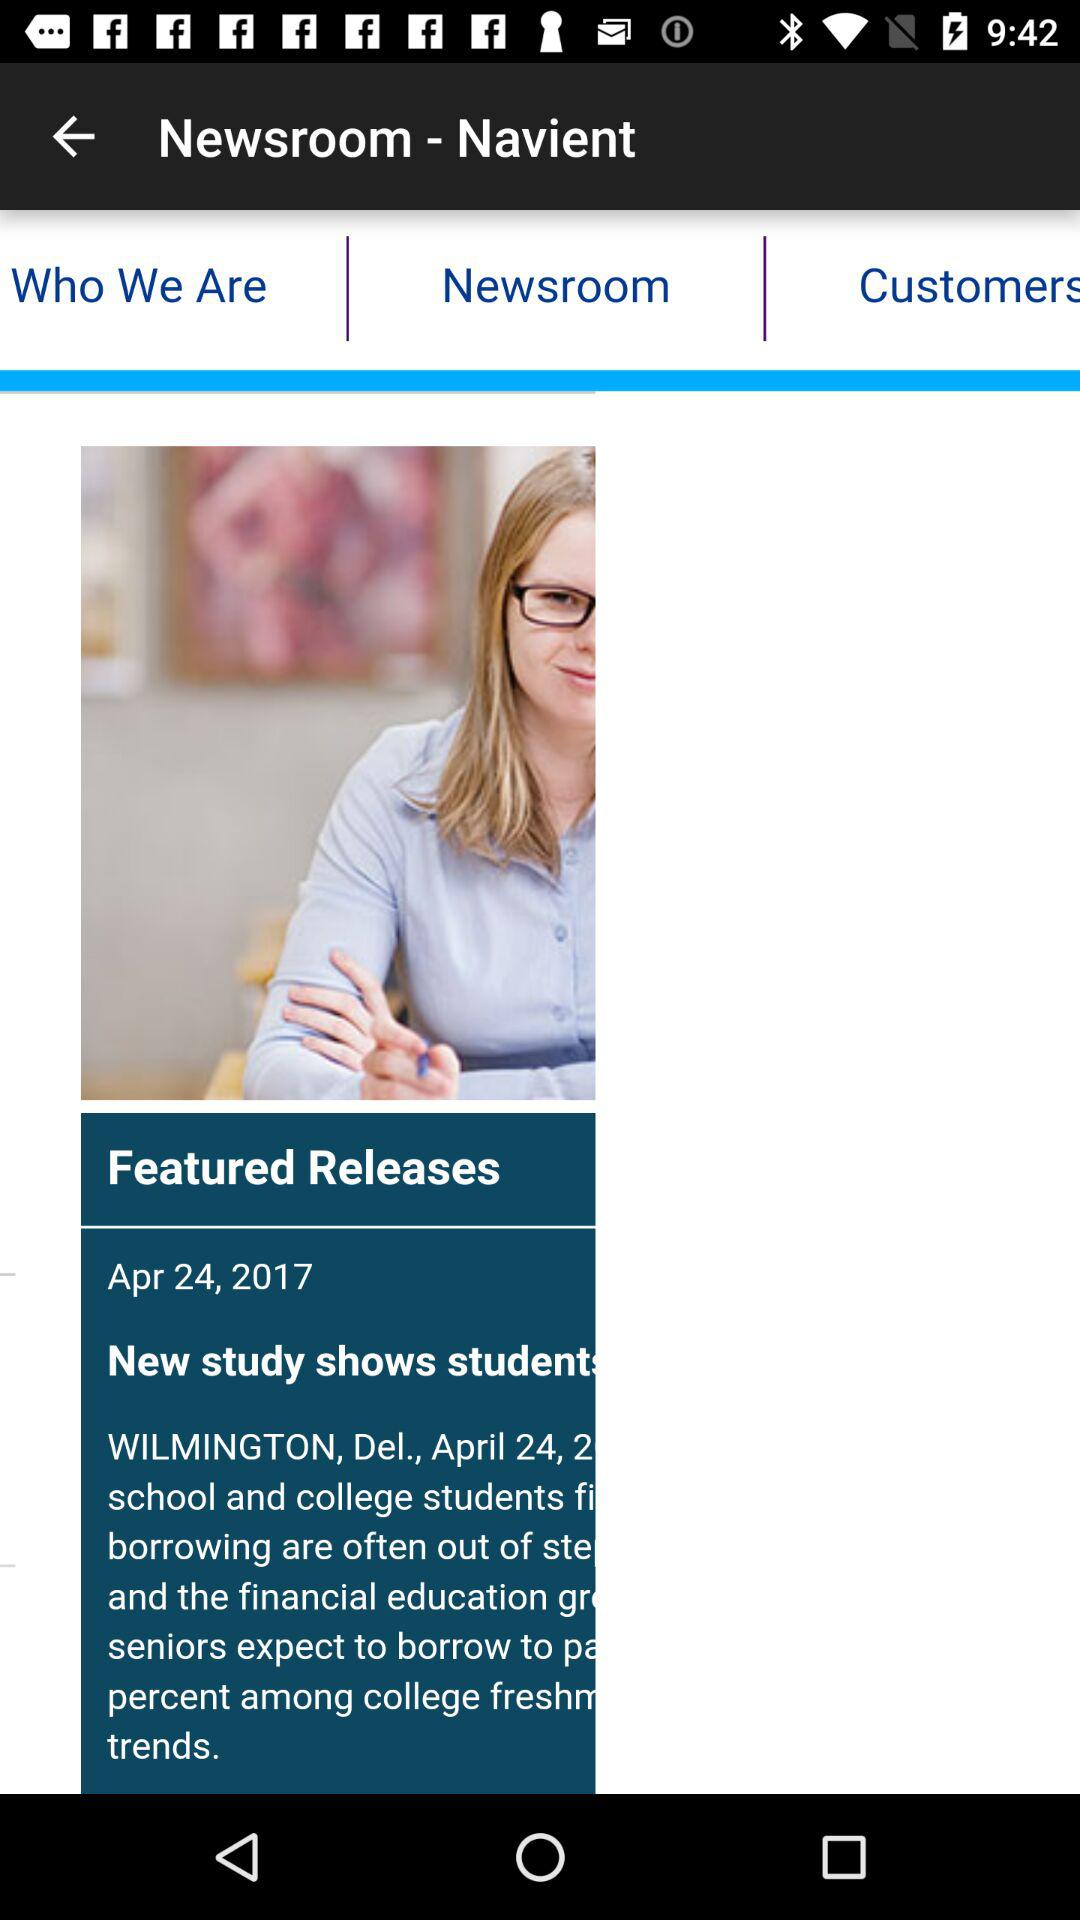When was the news released? The news was released on April 24, 2017. 